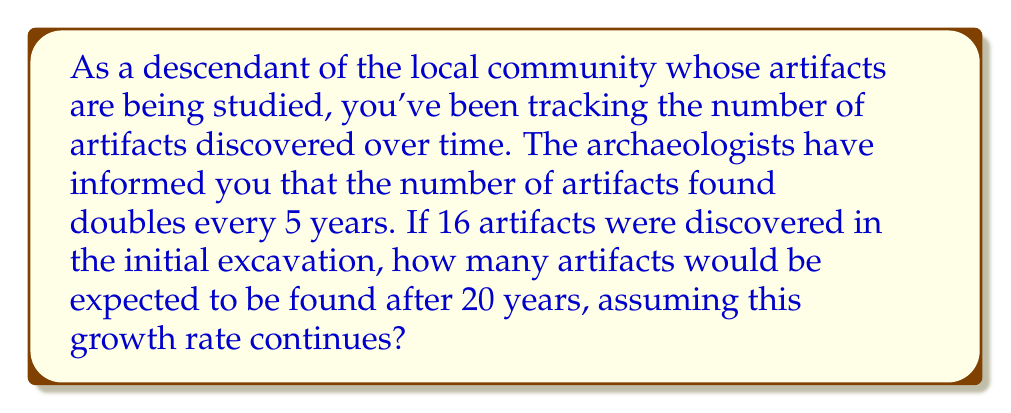Show me your answer to this math problem. Let's approach this step-by-step:

1) We're dealing with exponential growth, where the number of artifacts doubles every 5 years.

2) The initial number of artifacts is 16, and we want to know the number after 20 years.

3) In 20 years, there are 4 doubling periods (20 ÷ 5 = 4).

4) We can express this mathematically as:

   $$ A = 16 \cdot 2^4 $$

   Where $A$ is the number of artifacts after 20 years, 16 is the initial number, and $2^4$ represents doubling 4 times.

5) Let's calculate:

   $$ A = 16 \cdot 2^4 $$
   $$ A = 16 \cdot 16 $$
   $$ A = 256 $$

6) We can also express this using the exponential growth formula:

   $$ A = P(1 + r)^t $$

   Where $P$ is the initial population (16), $r$ is the growth rate per period (1, as it doubles), and $t$ is the number of periods (4).

   $$ A = 16(1 + 1)^4 = 16 \cdot 2^4 = 256 $$

This confirms our earlier calculation.
Answer: 256 artifacts 